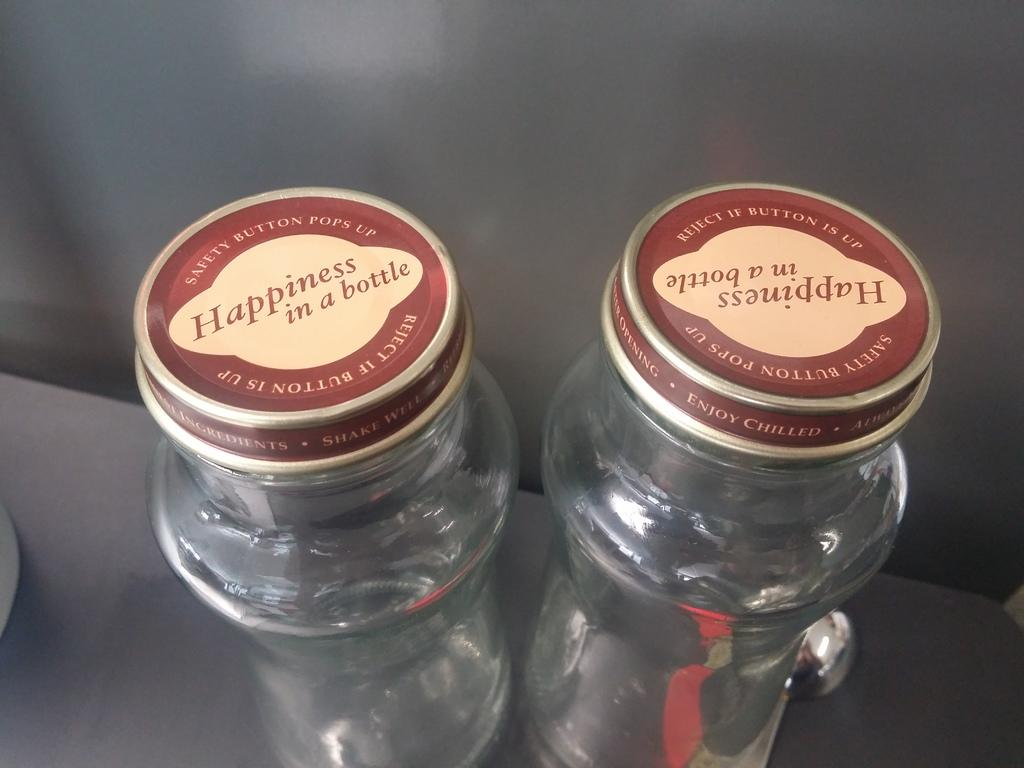<image>
Create a compact narrative representing the image presented. Two empty glass bottles say "Happiness in a bottle" on top. 